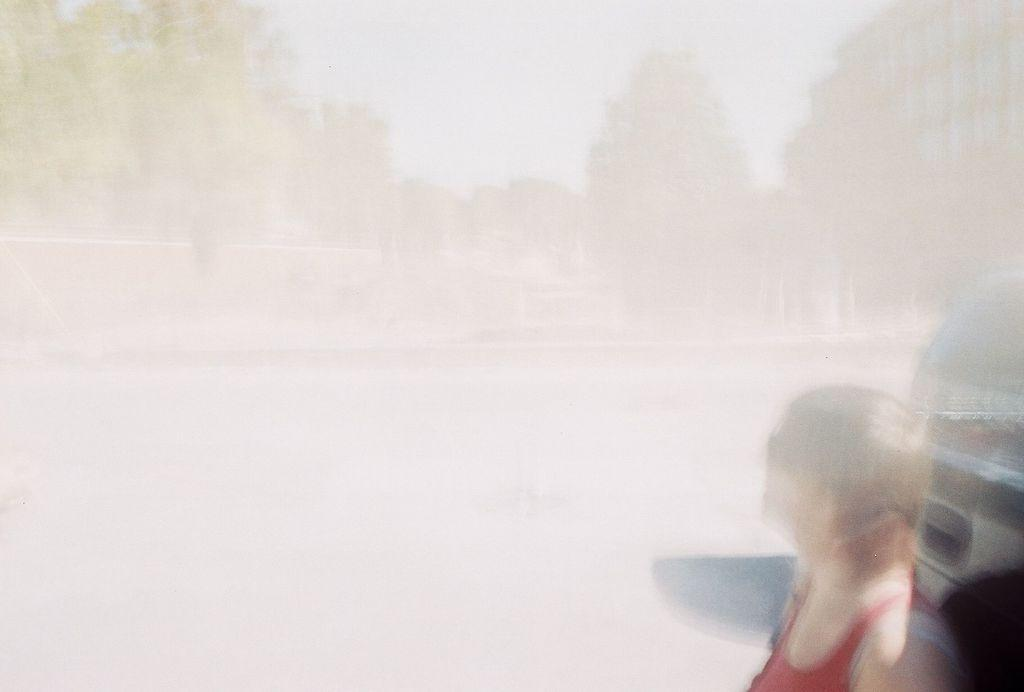What is the main subject in the image? There is a person in the image. Can you describe any other objects or elements in the image? There is a vehicle in the image, but it is truncated, and there are trees visible in the image. What can be seen in the background of the image? The background of the image is blurred, and there is at least one building visible. What part of the natural environment is visible in the image? Trees and the sky are visible in the image. What type of bead is being used to measure pollution levels in the image? There is no bead or reference to pollution measurement in the image. 